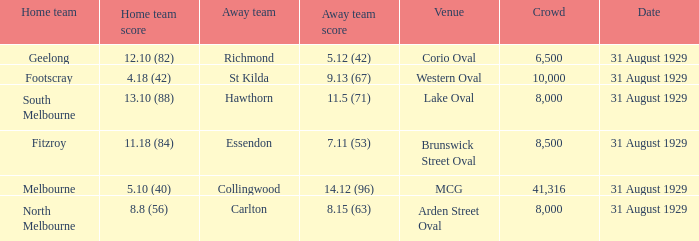What is the score of the away team when the crowd was larger than 8,000? 9.13 (67), 7.11 (53), 14.12 (96). Could you parse the entire table? {'header': ['Home team', 'Home team score', 'Away team', 'Away team score', 'Venue', 'Crowd', 'Date'], 'rows': [['Geelong', '12.10 (82)', 'Richmond', '5.12 (42)', 'Corio Oval', '6,500', '31 August 1929'], ['Footscray', '4.18 (42)', 'St Kilda', '9.13 (67)', 'Western Oval', '10,000', '31 August 1929'], ['South Melbourne', '13.10 (88)', 'Hawthorn', '11.5 (71)', 'Lake Oval', '8,000', '31 August 1929'], ['Fitzroy', '11.18 (84)', 'Essendon', '7.11 (53)', 'Brunswick Street Oval', '8,500', '31 August 1929'], ['Melbourne', '5.10 (40)', 'Collingwood', '14.12 (96)', 'MCG', '41,316', '31 August 1929'], ['North Melbourne', '8.8 (56)', 'Carlton', '8.15 (63)', 'Arden Street Oval', '8,000', '31 August 1929']]} 